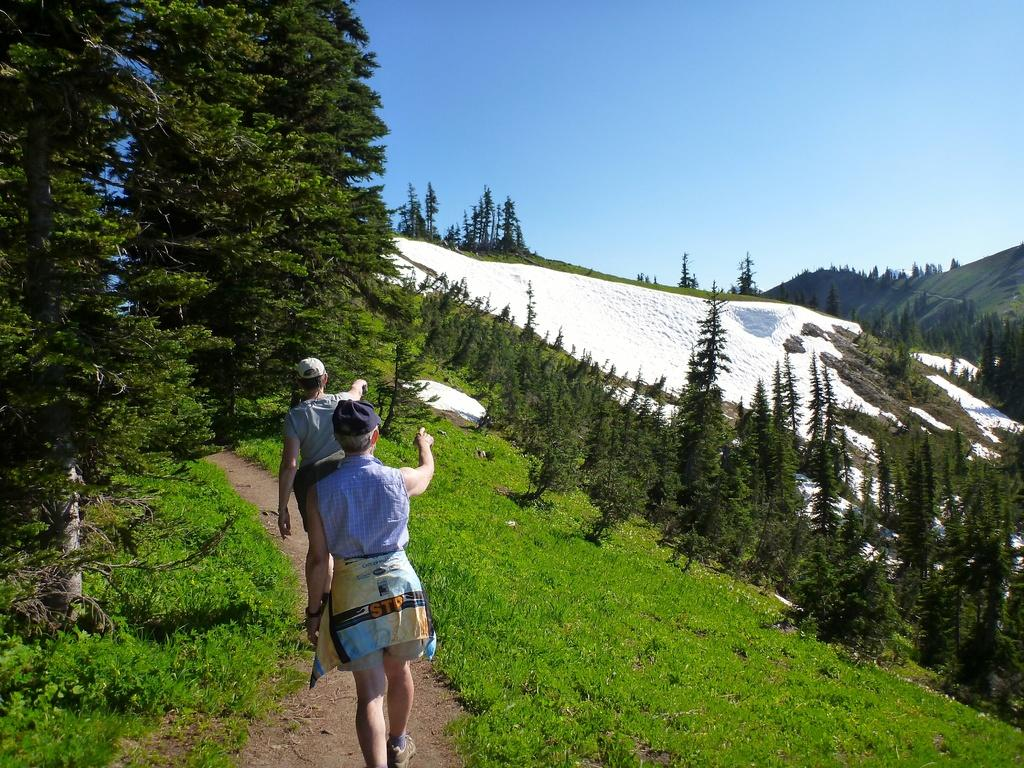What is the main feature of the landscape in the image? There is a hill in the image. What are the two persons in the image doing? The two persons are walking on the hill. What type of vegetation is present on the hill? There are trees on the hill. What is the condition of the hill in the image? The hill is covered with snow. What can be seen in the background of the image? The sky is visible in the background of the image. How many beds can be seen in the image? There are no beds present in the image; it features a hill with two persons walking on it. What type of meat is being prepared by the hand in the image? There is no hand or meat preparation present in the image. 